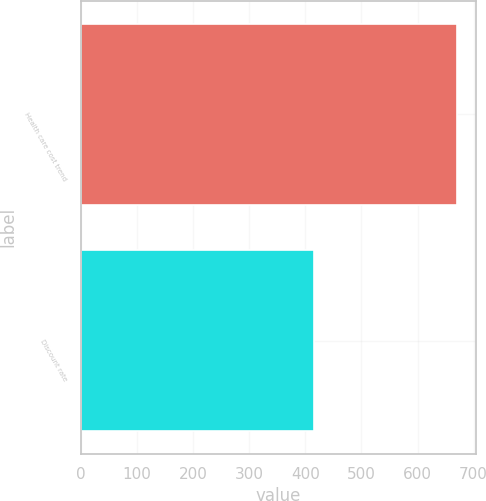Convert chart to OTSL. <chart><loc_0><loc_0><loc_500><loc_500><bar_chart><fcel>Health care cost trend<fcel>Discount rate<nl><fcel>670<fcel>416<nl></chart> 